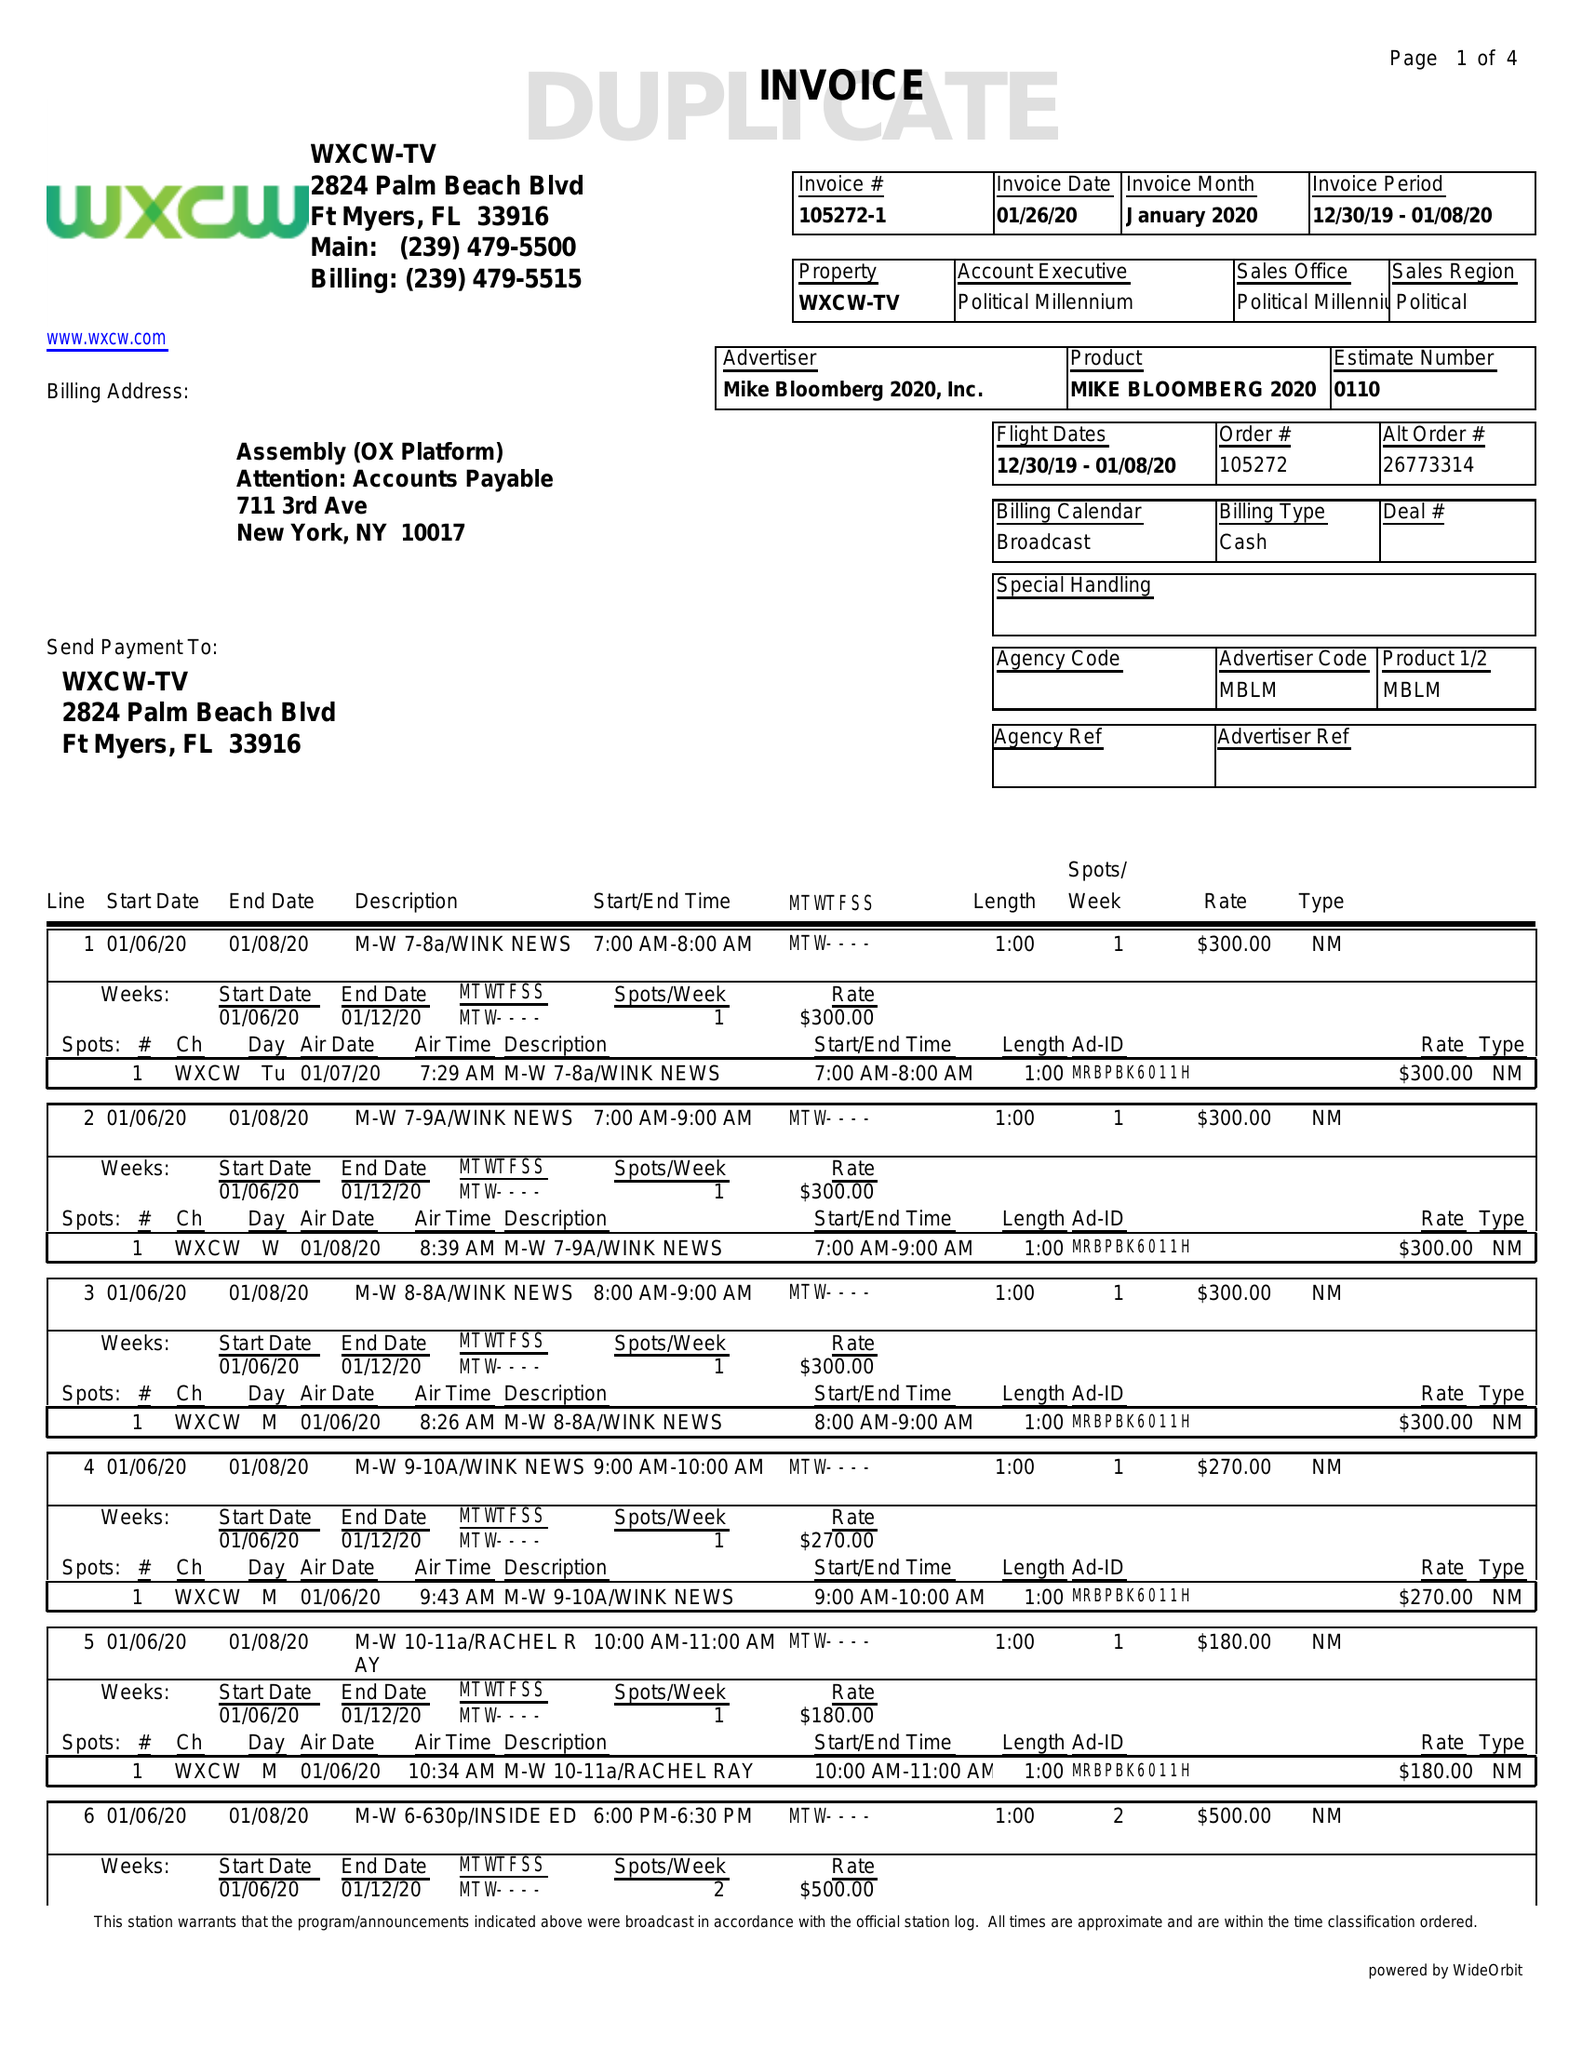What is the value for the flight_from?
Answer the question using a single word or phrase. 12/30/19 